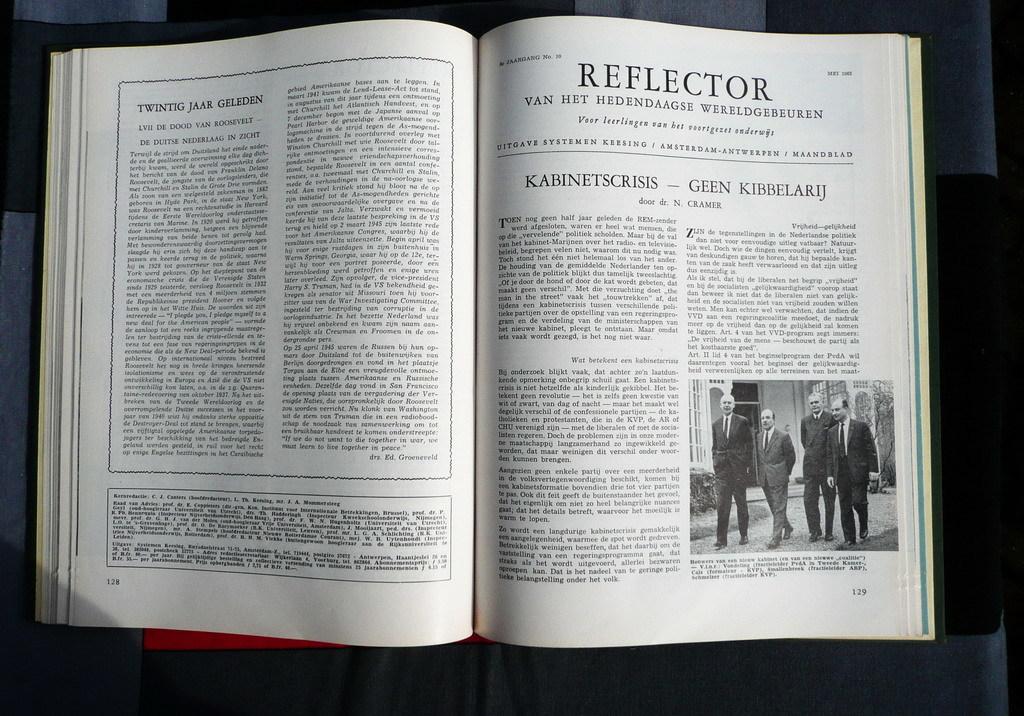What is the title on the right page?
Provide a succinct answer. Reflector. What is the right page number?
Your response must be concise. 129. 